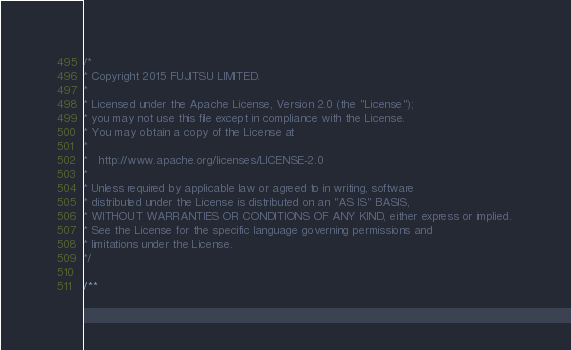Convert code to text. <code><loc_0><loc_0><loc_500><loc_500><_Java_>/* 
* Copyright 2015 FUJITSU LIMITED. 
* 
* Licensed under the Apache License, Version 2.0 (the "License"); 
* you may not use this file except in compliance with the License. 
* You may obtain a copy of the License at 
* 
*   http://www.apache.org/licenses/LICENSE-2.0 
* 
* Unless required by applicable law or agreed to in writing, software 
* distributed under the License is distributed on an "AS IS" BASIS, 
* WITHOUT WARRANTIES OR CONDITIONS OF ANY KIND, either express or implied. 
* See the License for the specific language governing permissions and 
* limitations under the License. 
*/

/**</code> 